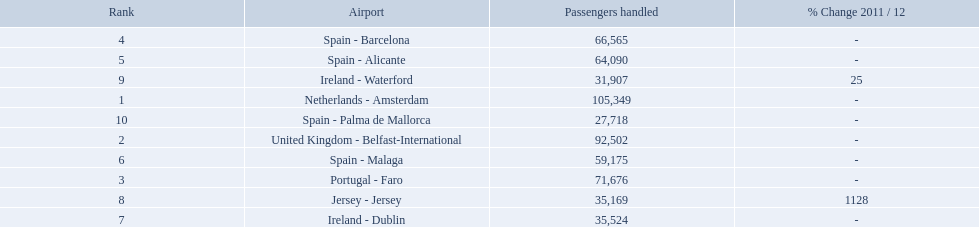What are all the airports in the top 10 busiest routes to and from london southend airport? Netherlands - Amsterdam, United Kingdom - Belfast-International, Portugal - Faro, Spain - Barcelona, Spain - Alicante, Spain - Malaga, Ireland - Dublin, Jersey - Jersey, Ireland - Waterford, Spain - Palma de Mallorca. Which airports are in portugal? Portugal - Faro. What is the highest number of passengers handled? 105,349. What is the destination of the passengers leaving the area that handles 105,349 travellers? Netherlands - Amsterdam. 